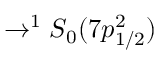Convert formula to latex. <formula><loc_0><loc_0><loc_500><loc_500>\rightarrow ^ { 1 } S _ { 0 } ( 7 p _ { 1 / 2 } ^ { 2 } )</formula> 